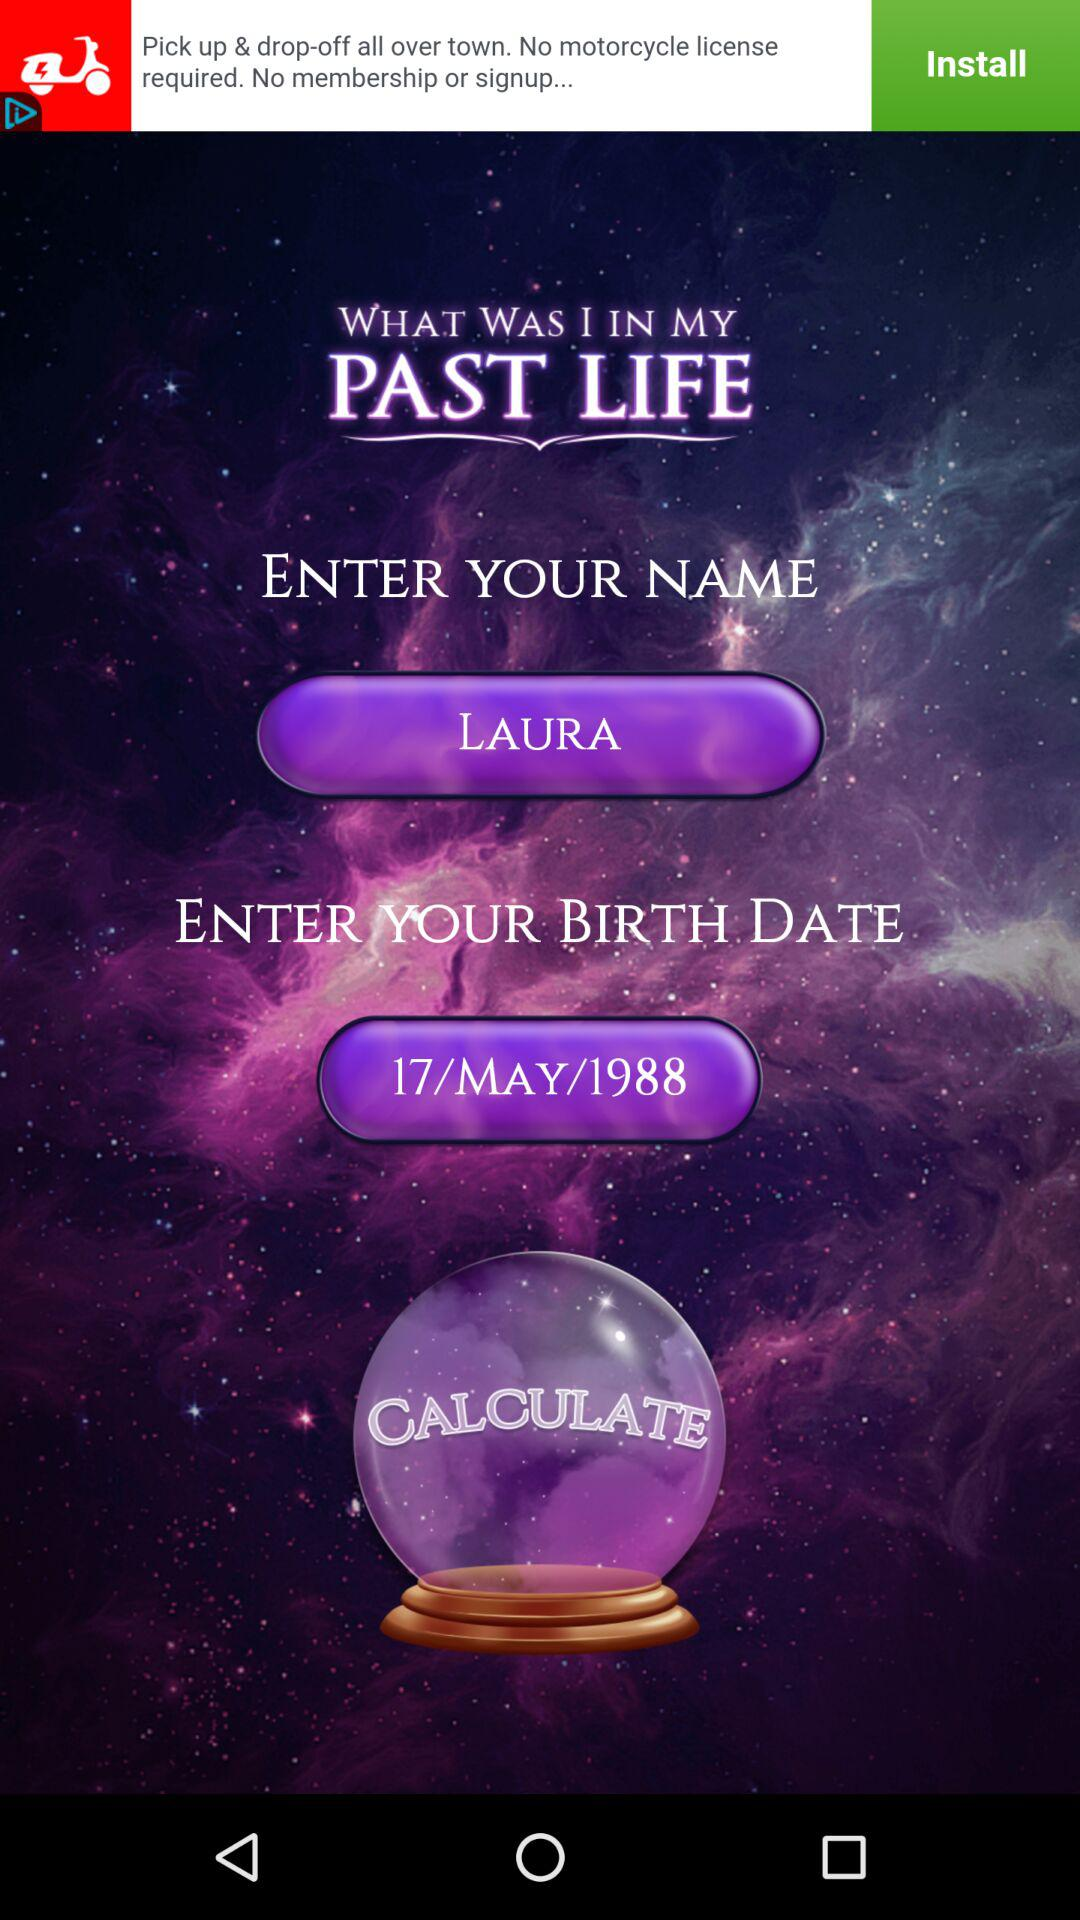What is the date of birth? The date of birth is May 17, 1988. 